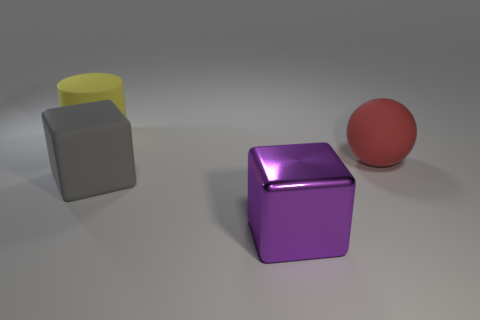Is there any other thing that is made of the same material as the purple cube?
Ensure brevity in your answer.  No. Does the big yellow cylinder have the same material as the large sphere?
Your response must be concise. Yes. What is the size of the rubber object that is both behind the big rubber cube and in front of the large yellow thing?
Make the answer very short. Large. How many purple objects are the same size as the gray cube?
Keep it short and to the point. 1. What size is the thing left of the big block that is left of the purple object?
Offer a very short reply. Large. Does the large matte thing that is in front of the large red object have the same shape as the object that is in front of the large gray rubber cube?
Ensure brevity in your answer.  Yes. There is a rubber thing that is both behind the big gray thing and on the right side of the cylinder; what is its color?
Make the answer very short. Red. The thing that is behind the big red ball is what color?
Give a very brief answer. Yellow. Are there any big gray blocks that are on the right side of the large rubber thing in front of the red object?
Make the answer very short. No. Is there another big thing that has the same material as the red object?
Offer a terse response. Yes. 